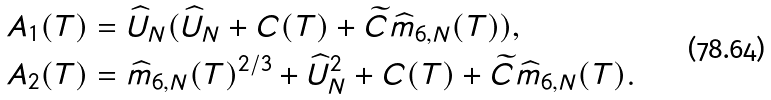Convert formula to latex. <formula><loc_0><loc_0><loc_500><loc_500>A _ { 1 } ( T ) & = \widehat { U } _ { N } ( \widehat { U } _ { N } + C ( T ) + \widetilde { C } \widehat { m } _ { 6 , N } ( T ) ) , \\ A _ { 2 } ( T ) & = \widehat { m } _ { 6 , N } ( T ) ^ { 2 / 3 } + \widehat { U } _ { N } ^ { 2 } + C ( T ) + \widetilde { C } \widehat { m } _ { 6 , N } ( T ) .</formula> 